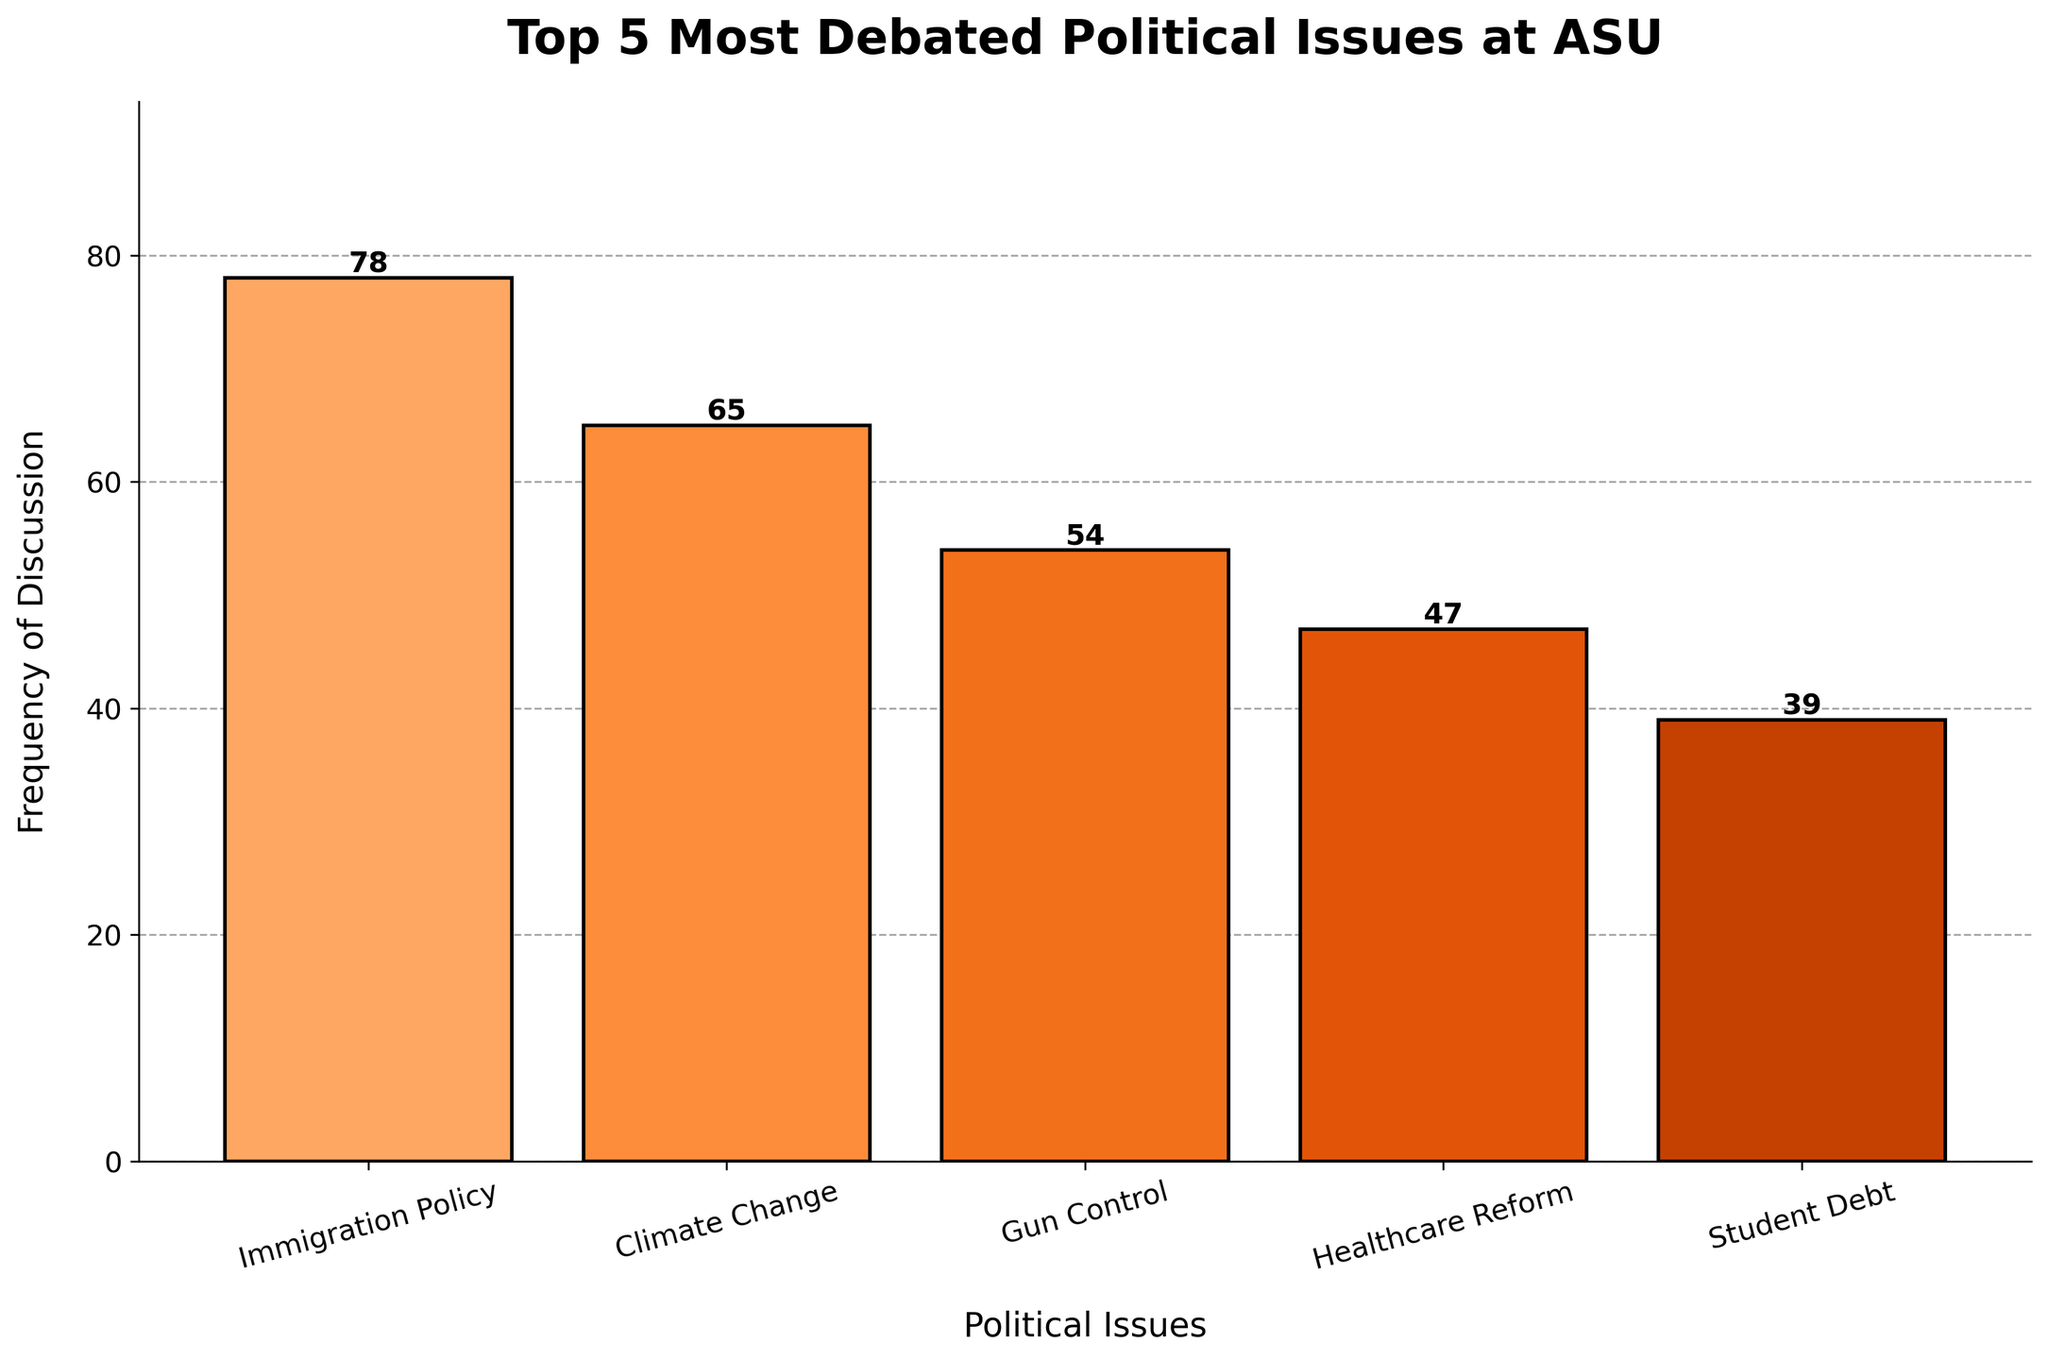Which political issue is debated the most at ASU? Look at the bar highest in height, which represents the issue with the highest frequency of discussion. The tallest bar corresponds to 'Immigration Policy' with a frequency of 78.
Answer: Immigration Policy Between 'Climate Change' and 'Healthcare Reform,' which issue is discussed more frequently? Compare the heights of the bars representing 'Climate Change' and 'Healthcare Reform.' The bar for 'Climate Change' is taller with a frequency of 65, while 'Healthcare Reform' has a lower frequency of 47.
Answer: Climate Change What is the combined frequency of discussions for 'Gun Control' and 'Student Debt'? Add the frequencies of the two issues: 'Gun Control' is 54 and 'Student Debt' is 39. The combined frequency is 54 + 39.
Answer: 93 Which issue has the lowest frequency of discussion? Find the shortest bar, which represents the issue with the lowest frequency. The shortest bar corresponds to 'Student Debt' with a frequency of 39.
Answer: Student Debt How many more times is 'Immigration Policy' discussed compared to 'Student Debt'? Subtract the frequency of 'Student Debt' from 'Immigration Policy': 78 - 39.
Answer: 39 Rank the issues in descending order of their discussion frequency. Start with the highest frequency and move to the lowest: Immigration Policy (78), Climate Change (65), Gun Control (54), Healthcare Reform (47), and Student Debt (39).
Answer: Immigration Policy > Climate Change > Gun Control > Healthcare Reform > Student Debt What is the average frequency of discussion for all the issues? Sum all the frequencies and divide by the number of issues: (78 + 65 + 54 + 47 + 39) / 5.
Answer: 56.6 Is 'Gun Control' discussed less frequently than 'Healthcare Reform'? Compare the bars visually: 'Gun Control' has a frequency of 54, and 'Healthcare Reform' has a frequency of 47. 'Gun Control' is discussed more frequently, not less.
Answer: No What's the frequency difference between the most and the least discussed issues? Subtract the frequency of the least discussed issue ('Student Debt') from the most discussed issue ('Immigration Policy'): 78 - 39.
Answer: 39 